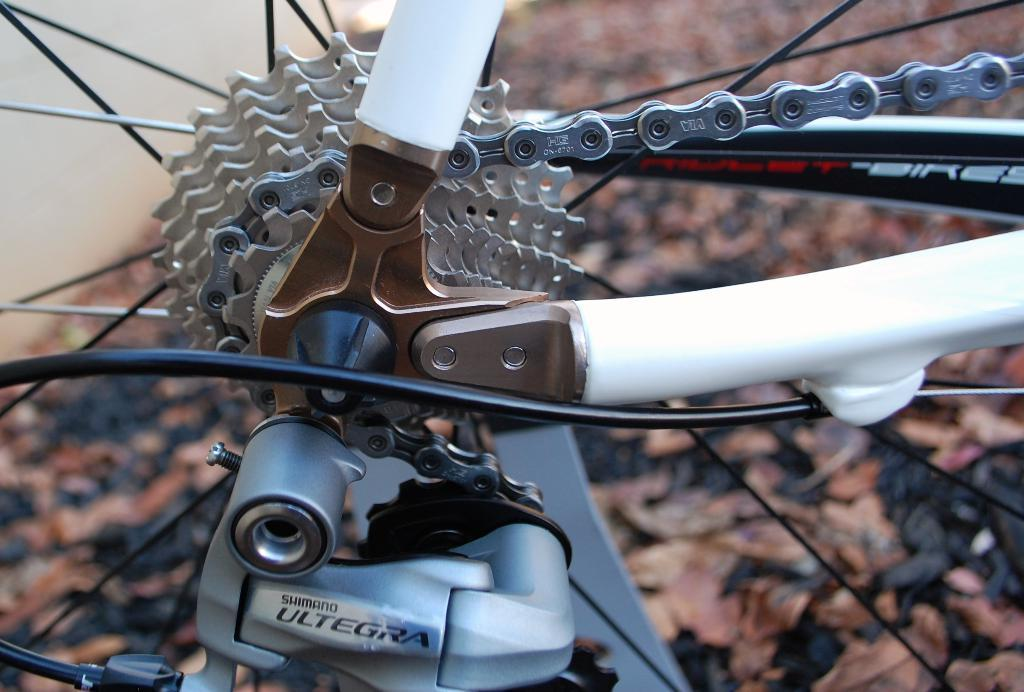What type of object has spokes in the image? The information provided does not specify the object with spokes, but we can confirm that there are spokes present in the image. What connects the spokes in the image? There is a chain connecting the spokes in the image. What other metal component is visible in the image? There is a metal rod in the image. How does the approval process work for the muscle in the image? There is no muscle present in the image, and therefore no approval process is relevant. 